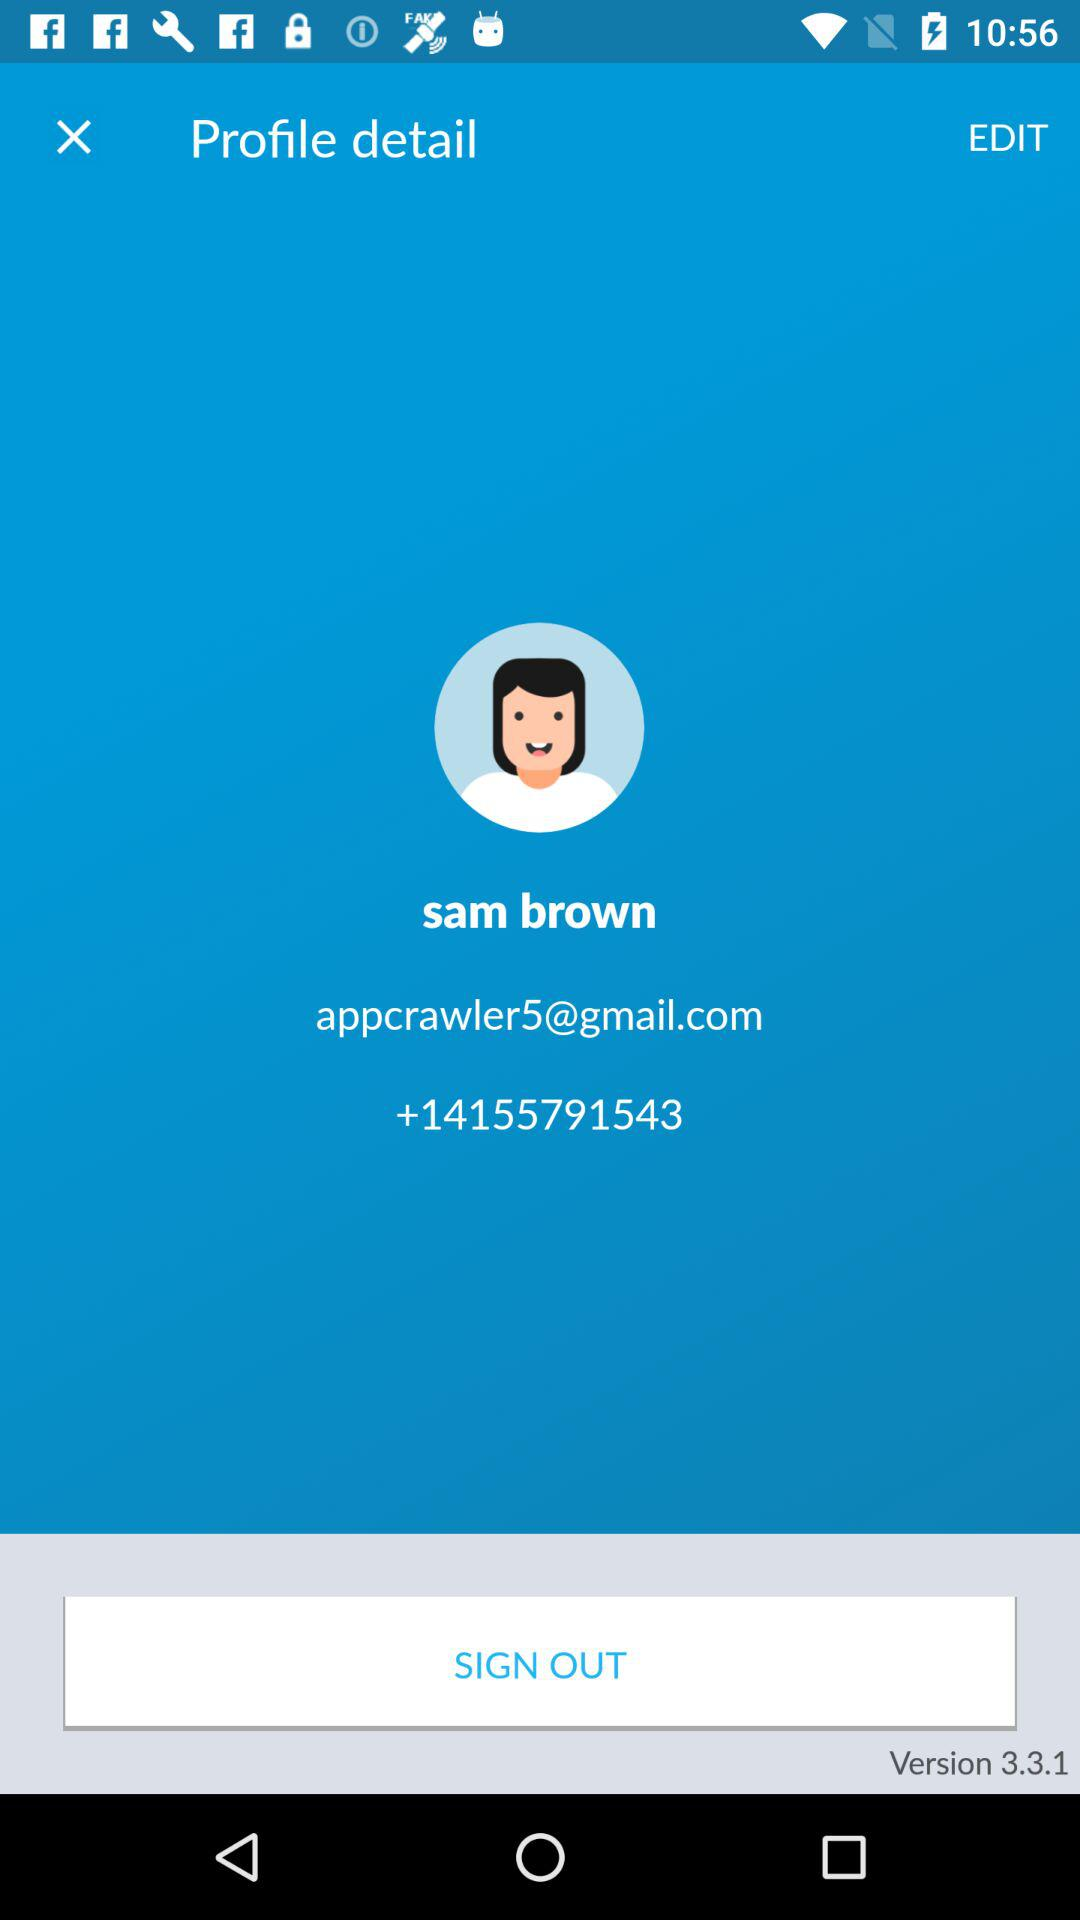What phone number has been given? The given phone number is +14155791543. 